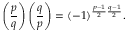Convert formula to latex. <formula><loc_0><loc_0><loc_500><loc_500>\left ( { \frac { p } { q } } \right ) \left ( { \frac { q } { p } } \right ) = ( - 1 ) ^ { { \frac { p - 1 } { 2 } } { \frac { q - 1 } { 2 } } } .</formula> 